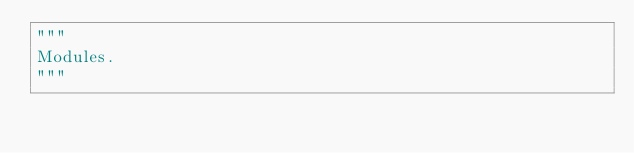Convert code to text. <code><loc_0><loc_0><loc_500><loc_500><_Python_>"""
Modules.
"""
</code> 